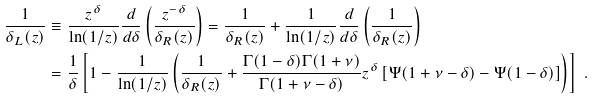<formula> <loc_0><loc_0><loc_500><loc_500>\frac { 1 } { \delta _ { L } ( z ) } & \equiv \frac { z ^ { \delta } } { \ln ( 1 / z ) } \frac { d } { d \delta } \left ( \frac { z ^ { - \delta } } { \delta _ { R } ( z ) } \right ) = \frac { 1 } { \delta _ { R } ( z ) } + \frac { 1 } { \ln ( 1 / z ) } \frac { d } { d \delta } \left ( \frac { 1 } { \delta _ { R } ( z ) } \right ) \\ & = \frac { 1 } { \delta } \left [ 1 - \frac { 1 } { \ln ( 1 / z ) } \left ( \frac { 1 } { \delta _ { R } ( z ) } + \frac { \Gamma ( 1 - \delta ) \Gamma ( 1 + \nu ) } { \Gamma ( 1 + \nu - \delta ) } z ^ { \delta } \left [ \Psi ( 1 + \nu - \delta ) - \Psi ( 1 - \delta ) \right ] \right ) \right ] \ .</formula> 